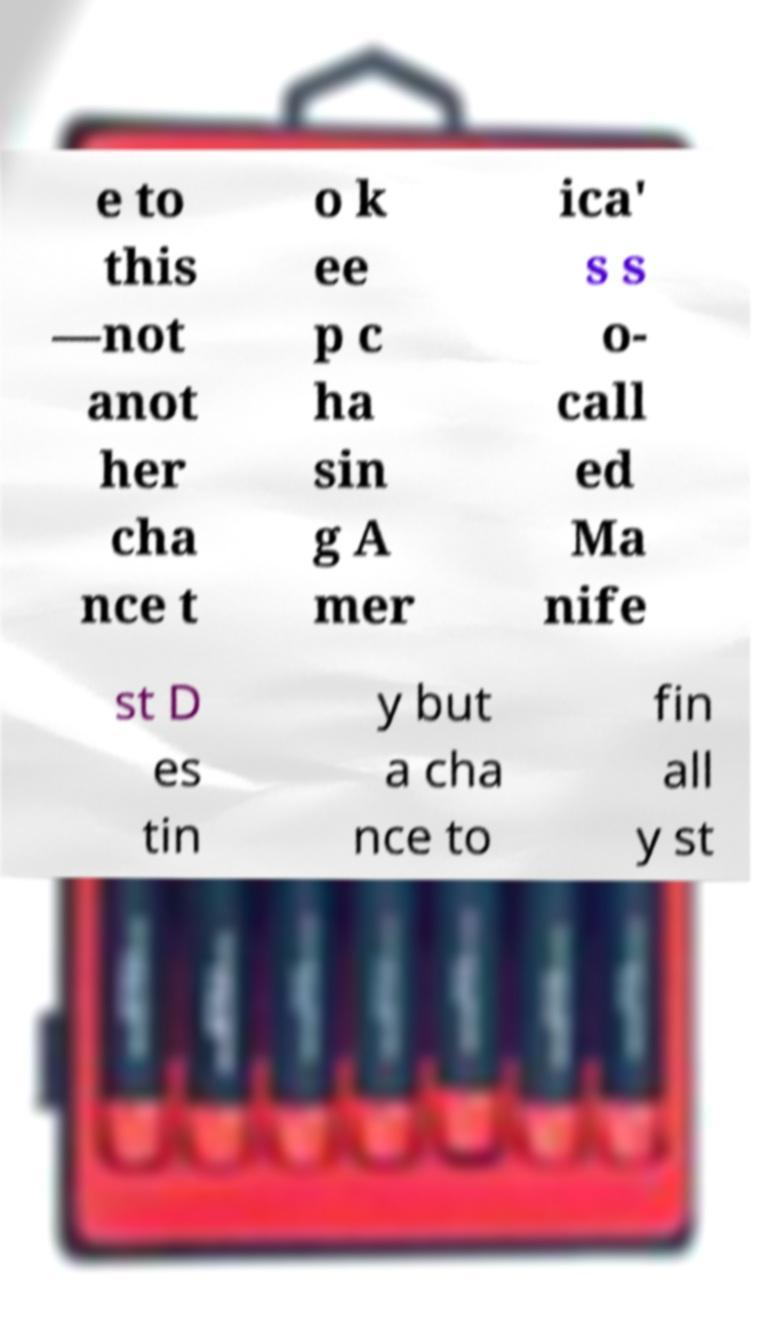What messages or text are displayed in this image? I need them in a readable, typed format. e to this —not anot her cha nce t o k ee p c ha sin g A mer ica' s s o- call ed Ma nife st D es tin y but a cha nce to fin all y st 